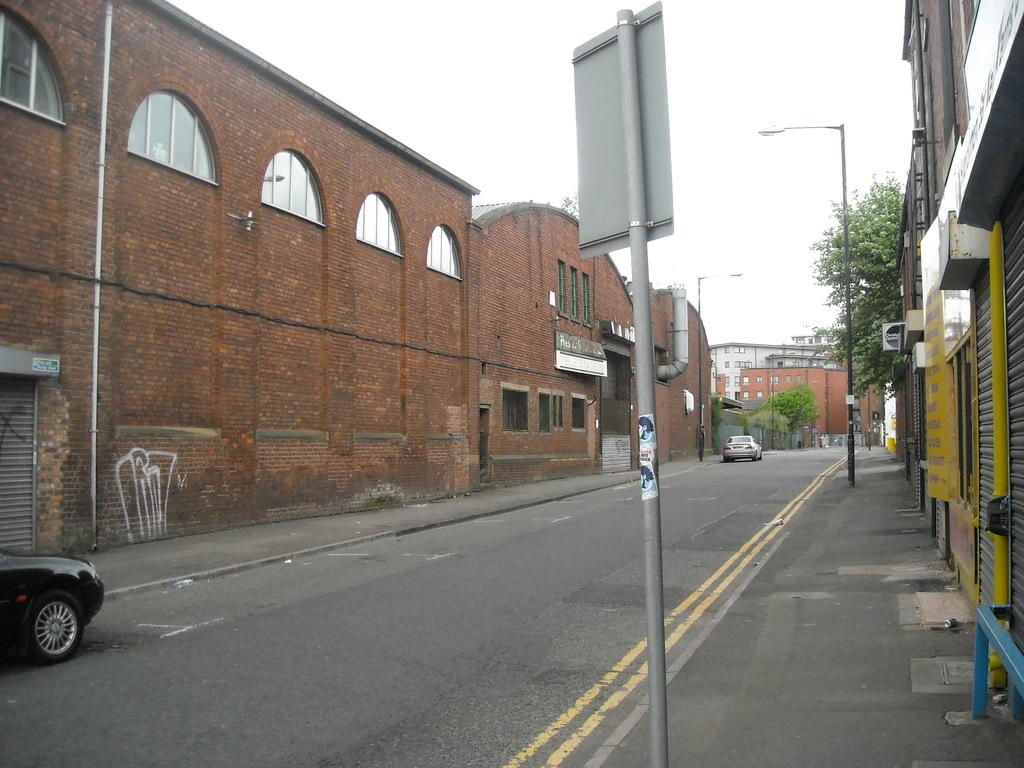What type of structures are present in the image? There are buildings in the image. What other natural elements can be seen in the image? There are trees in the image. What are the vertical objects in the image? There are poles in the image. What is at the bottom of the image? There is a road at the bottom of the image. What type of vehicles are on the road? There are cars on the road. What can be seen in the background of the image? The sky is visible in the background of the image. Can you see a ring hanging from the curtain in the image? There is no curtain or ring present in the image. What type of weather can be inferred from the presence of thunder in the image? There is no thunder present in the image, so it cannot be used to infer the weather. 